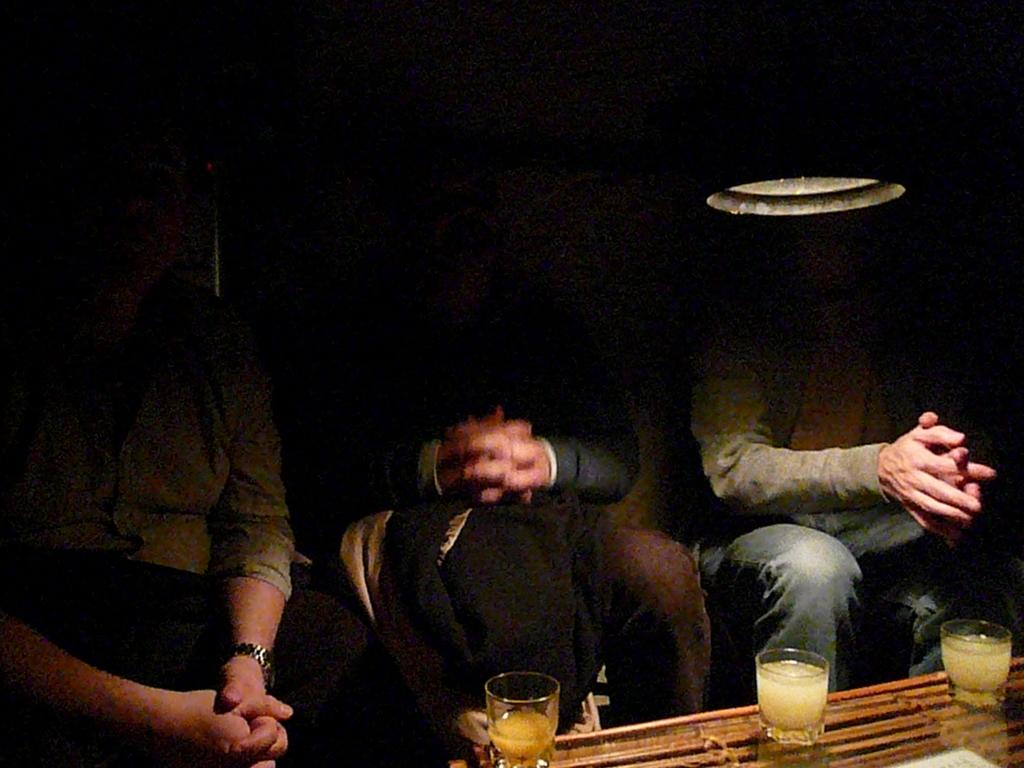Who or what is present in the image? There are people in the image. What object can be seen in the image that might be used for eating or drinking? There is a table in the image, and glasses are placed on the table. Can you describe the source of light in the image? There is a light in the image. What type of rock is visible on the ground in the image? There is no rock or ground visible in the image; it appears to be an indoor setting. 